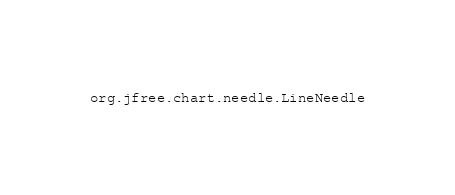Convert code to text. <code><loc_0><loc_0><loc_500><loc_500><_Rust_>org.jfree.chart.needle.LineNeedle
</code> 